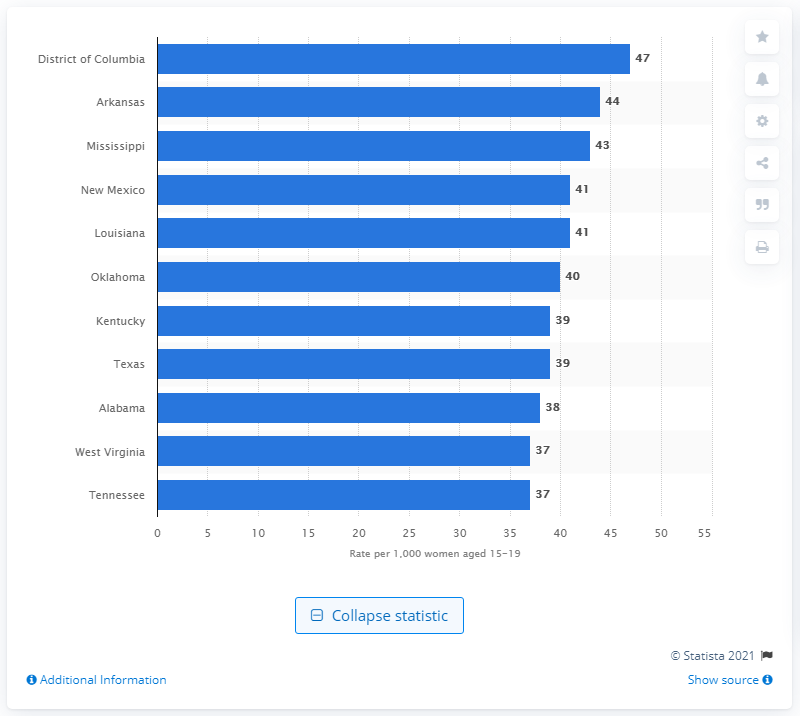Point out several critical features in this image. According to data, the District of Columbia has the highest teenage pregnancy rate among all states in the United States. 